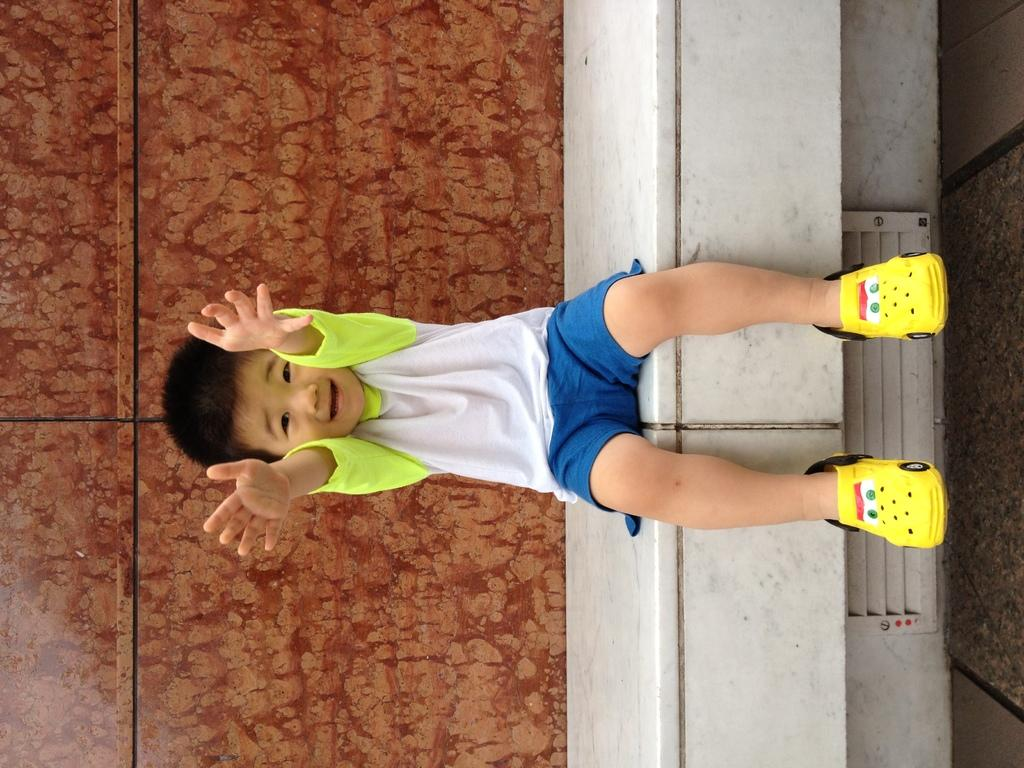Who is the main subject in the image? There is a boy in the image. What is the boy doing in the image? The boy is sitting on a platform. What else can be seen in the image besides the boy? There are objects in the image. What is visible in the background of the image? There is a wall in the background of the image. What color is the thumb of the boy in the image? There is no thumb visible in the image, as the boy is sitting on a platform and not actively using his hands. 